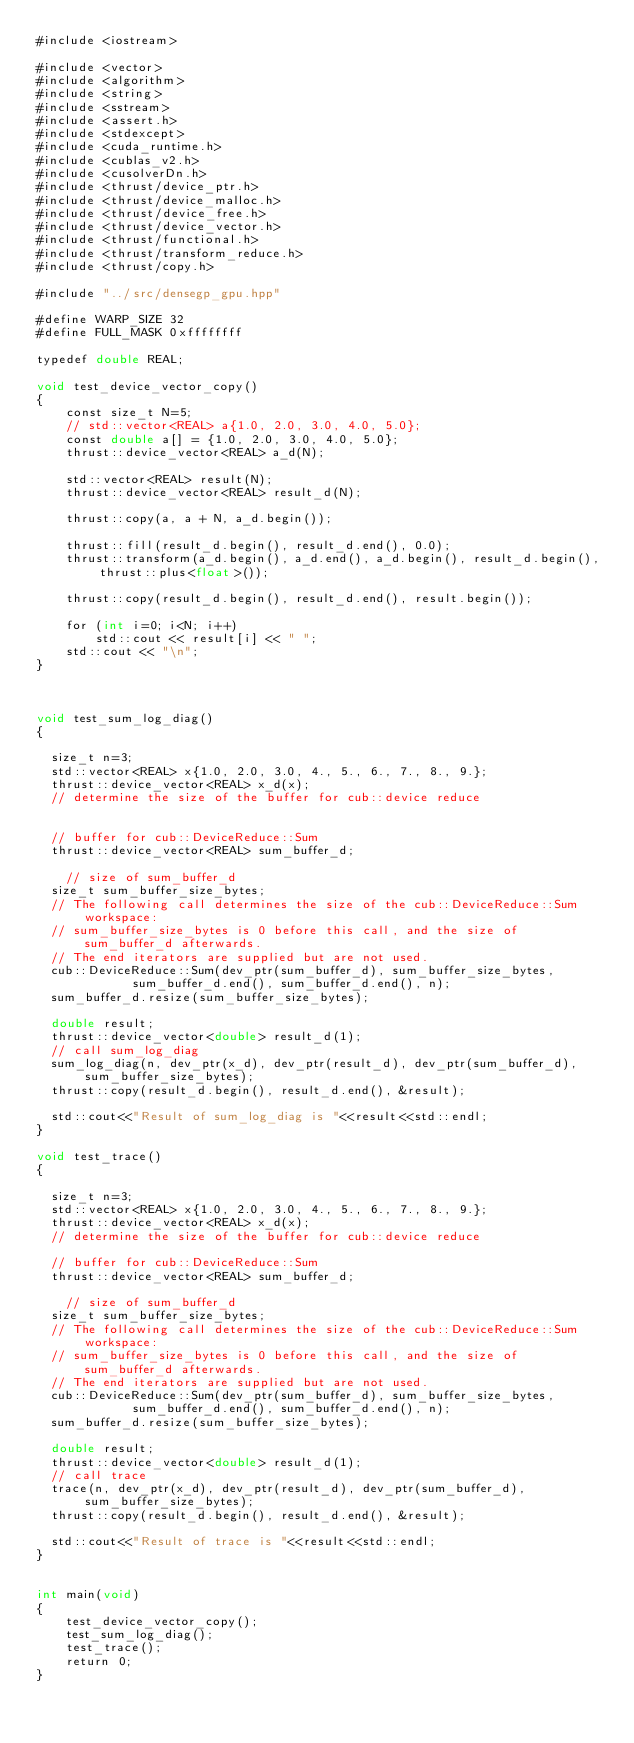<code> <loc_0><loc_0><loc_500><loc_500><_Cuda_>#include <iostream>

#include <vector>
#include <algorithm>
#include <string>
#include <sstream>
#include <assert.h>
#include <stdexcept>
#include <cuda_runtime.h>
#include <cublas_v2.h>
#include <cusolverDn.h>
#include <thrust/device_ptr.h>
#include <thrust/device_malloc.h>
#include <thrust/device_free.h>
#include <thrust/device_vector.h>
#include <thrust/functional.h>
#include <thrust/transform_reduce.h>
#include <thrust/copy.h>

#include "../src/densegp_gpu.hpp"

#define WARP_SIZE 32
#define FULL_MASK 0xffffffff

typedef double REAL;

void test_device_vector_copy()
{
    const size_t N=5;
    // std::vector<REAL> a{1.0, 2.0, 3.0, 4.0, 5.0};
    const double a[] = {1.0, 2.0, 3.0, 4.0, 5.0};
    thrust::device_vector<REAL> a_d(N);

    std::vector<REAL> result(N);
    thrust::device_vector<REAL> result_d(N);

    thrust::copy(a, a + N, a_d.begin());

    thrust::fill(result_d.begin(), result_d.end(), 0.0);
    thrust::transform(a_d.begin(), a_d.end(), a_d.begin(), result_d.begin(), thrust::plus<float>());

    thrust::copy(result_d.begin(), result_d.end(), result.begin());

    for (int i=0; i<N; i++)
        std::cout << result[i] << " ";
    std::cout << "\n";
}



void test_sum_log_diag()
{

  size_t n=3;
  std::vector<REAL> x{1.0, 2.0, 3.0, 4., 5., 6., 7., 8., 9.};
  thrust::device_vector<REAL> x_d(x);
  // determine the size of the buffer for cub::device reduce


  // buffer for cub::DeviceReduce::Sum
  thrust::device_vector<REAL> sum_buffer_d;

    // size of sum_buffer_d
  size_t sum_buffer_size_bytes;
  // The following call determines the size of the cub::DeviceReduce::Sum workspace:
  // sum_buffer_size_bytes is 0 before this call, and the size of sum_buffer_d afterwards.
  // The end iterators are supplied but are not used.
  cub::DeviceReduce::Sum(dev_ptr(sum_buffer_d), sum_buffer_size_bytes,
			 sum_buffer_d.end(), sum_buffer_d.end(), n);
  sum_buffer_d.resize(sum_buffer_size_bytes);

  double result;
  thrust::device_vector<double> result_d(1);
  // call sum_log_diag
  sum_log_diag(n, dev_ptr(x_d), dev_ptr(result_d), dev_ptr(sum_buffer_d), sum_buffer_size_bytes);
  thrust::copy(result_d.begin(), result_d.end(), &result);

  std::cout<<"Result of sum_log_diag is "<<result<<std::endl;
}

void test_trace()
{

  size_t n=3;
  std::vector<REAL> x{1.0, 2.0, 3.0, 4., 5., 6., 7., 8., 9.};
  thrust::device_vector<REAL> x_d(x);
  // determine the size of the buffer for cub::device reduce

  // buffer for cub::DeviceReduce::Sum
  thrust::device_vector<REAL> sum_buffer_d;

    // size of sum_buffer_d
  size_t sum_buffer_size_bytes;
  // The following call determines the size of the cub::DeviceReduce::Sum workspace:
  // sum_buffer_size_bytes is 0 before this call, and the size of sum_buffer_d afterwards.
  // The end iterators are supplied but are not used.
  cub::DeviceReduce::Sum(dev_ptr(sum_buffer_d), sum_buffer_size_bytes,
			 sum_buffer_d.end(), sum_buffer_d.end(), n);
  sum_buffer_d.resize(sum_buffer_size_bytes);

  double result;
  thrust::device_vector<double> result_d(1);
  // call trace
  trace(n, dev_ptr(x_d), dev_ptr(result_d), dev_ptr(sum_buffer_d), sum_buffer_size_bytes);
  thrust::copy(result_d.begin(), result_d.end(), &result);

  std::cout<<"Result of trace is "<<result<<std::endl;
}


int main(void)
{
    test_device_vector_copy();
    test_sum_log_diag();
    test_trace();
    return 0;
}
</code> 